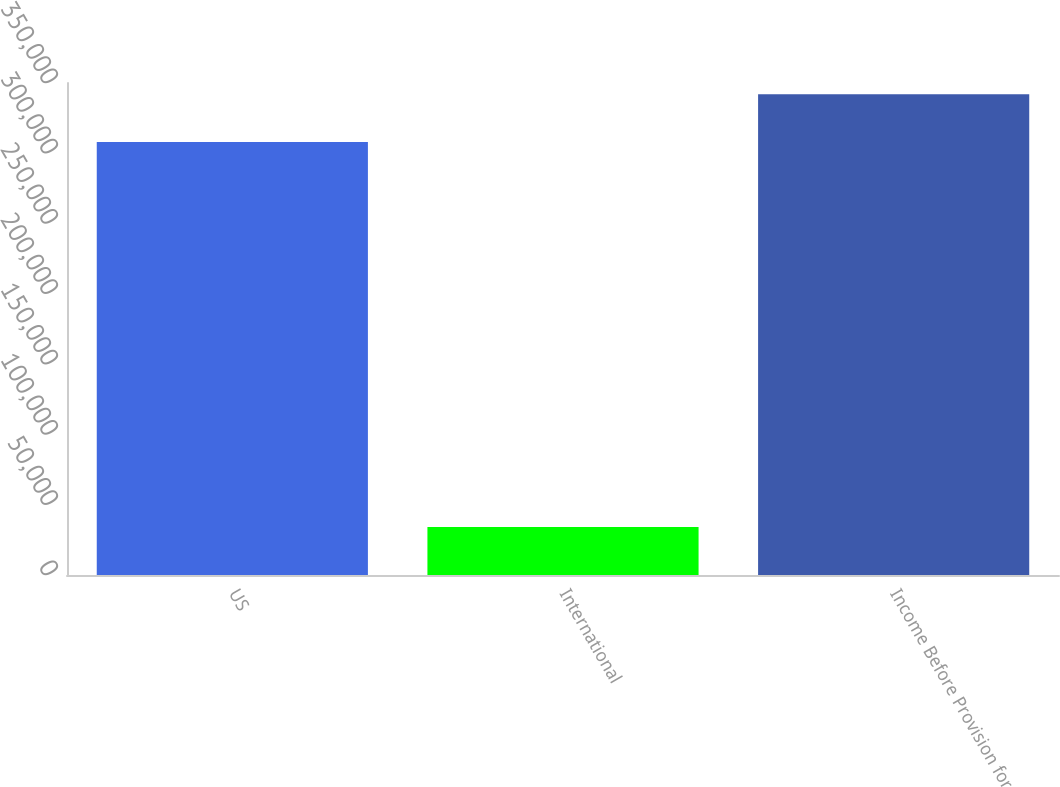Convert chart. <chart><loc_0><loc_0><loc_500><loc_500><bar_chart><fcel>US<fcel>International<fcel>Income Before Provision for<nl><fcel>308003<fcel>34063<fcel>342066<nl></chart> 